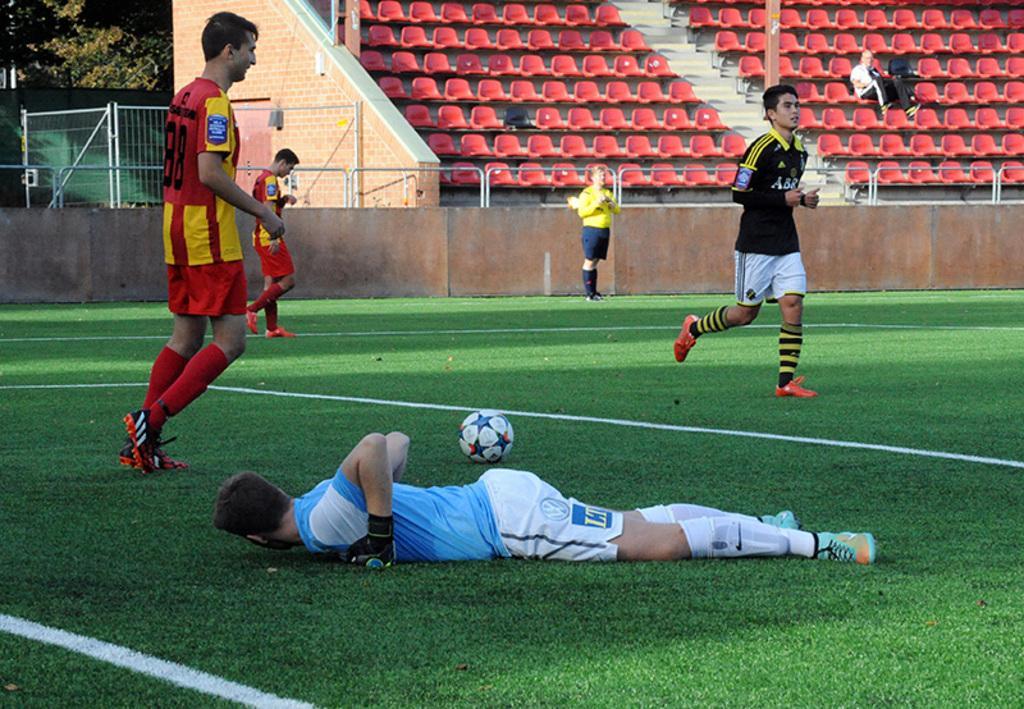Please provide a concise description of this image. In this image there are people. At the bottom there is a man lying on the ground. There is a ball. In the background we can see bleachers. On the left there is a grille and we can see a tree. 